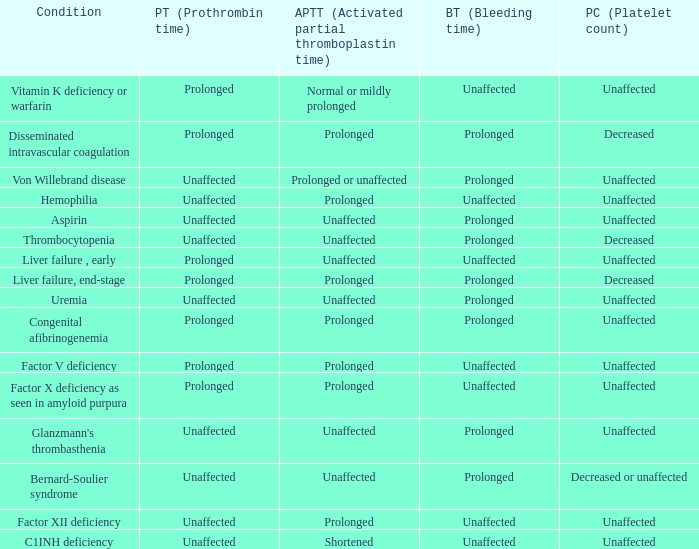Which Condition has an unaffected Prothrombin time and a Bleeding time, and a Partial thromboplastin time of prolonged? Hemophilia, Factor XII deficiency. 